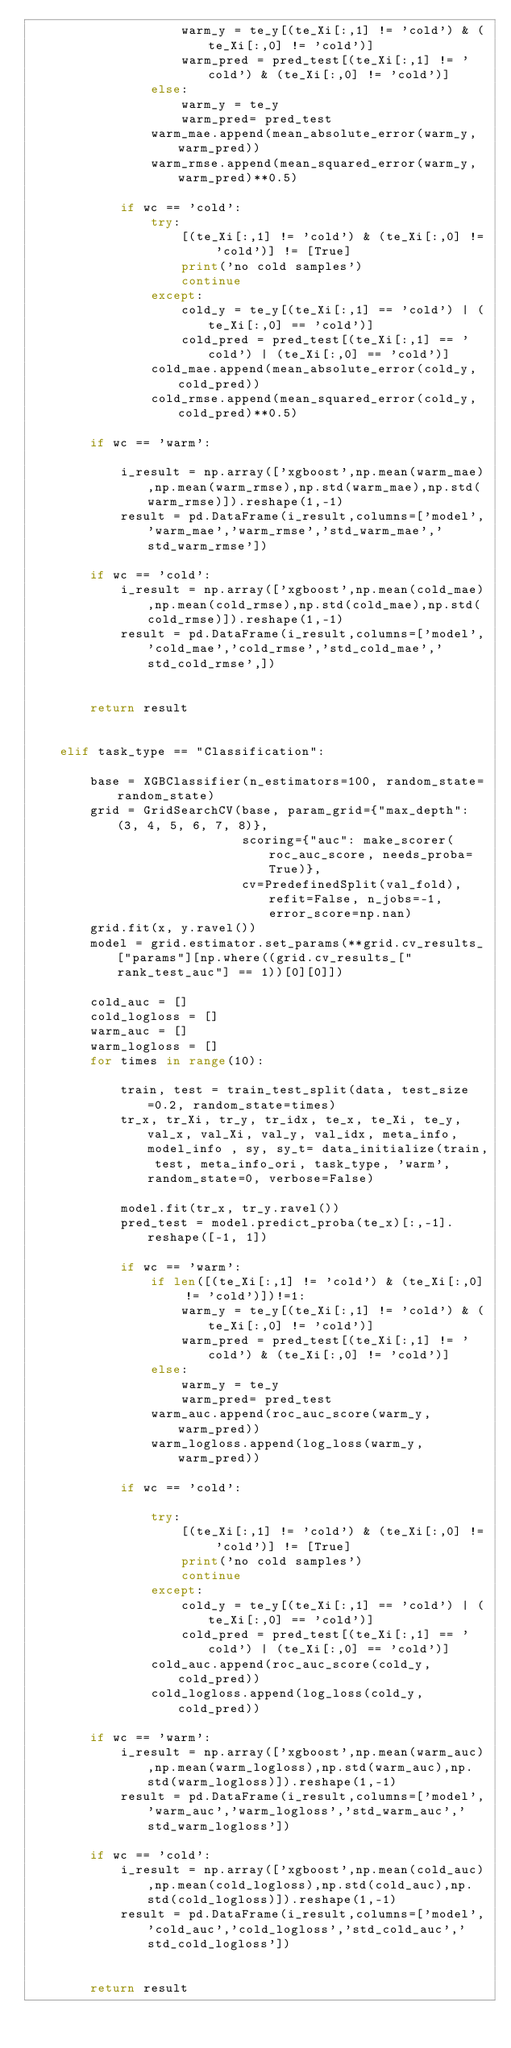Convert code to text. <code><loc_0><loc_0><loc_500><loc_500><_Python_>                    warm_y = te_y[(te_Xi[:,1] != 'cold') & (te_Xi[:,0] != 'cold')]
                    warm_pred = pred_test[(te_Xi[:,1] != 'cold') & (te_Xi[:,0] != 'cold')]
                else:
                    warm_y = te_y
                    warm_pred= pred_test
                warm_mae.append(mean_absolute_error(warm_y,warm_pred))
                warm_rmse.append(mean_squared_error(warm_y,warm_pred)**0.5)
                
            if wc == 'cold':
                try:
                    [(te_Xi[:,1] != 'cold') & (te_Xi[:,0] != 'cold')] != [True]
                    print('no cold samples')
                    continue
                except:
                    cold_y = te_y[(te_Xi[:,1] == 'cold') | (te_Xi[:,0] == 'cold')]
                    cold_pred = pred_test[(te_Xi[:,1] == 'cold') | (te_Xi[:,0] == 'cold')]
                cold_mae.append(mean_absolute_error(cold_y,cold_pred))
                cold_rmse.append(mean_squared_error(cold_y,cold_pred)**0.5)

        if wc == 'warm':
            
            i_result = np.array(['xgboost',np.mean(warm_mae),np.mean(warm_rmse),np.std(warm_mae),np.std(warm_rmse)]).reshape(1,-1)
            result = pd.DataFrame(i_result,columns=['model','warm_mae','warm_rmse','std_warm_mae','std_warm_rmse'])

        if wc == 'cold':  
            i_result = np.array(['xgboost',np.mean(cold_mae),np.mean(cold_rmse),np.std(cold_mae),np.std(cold_rmse)]).reshape(1,-1)
            result = pd.DataFrame(i_result,columns=['model','cold_mae','cold_rmse','std_cold_mae','std_cold_rmse',])
        

        return result


    elif task_type == "Classification":

        base = XGBClassifier(n_estimators=100, random_state=random_state)
        grid = GridSearchCV(base, param_grid={"max_depth": (3, 4, 5, 6, 7, 8)},
                            scoring={"auc": make_scorer(roc_auc_score, needs_proba=True)},
                            cv=PredefinedSplit(val_fold), refit=False, n_jobs=-1, error_score=np.nan)
        grid.fit(x, y.ravel())
        model = grid.estimator.set_params(**grid.cv_results_["params"][np.where((grid.cv_results_["rank_test_auc"] == 1))[0][0]])
        
        cold_auc = []
        cold_logloss = []
        warm_auc = []
        warm_logloss = []
        for times in range(10):
            
            train, test = train_test_split(data, test_size=0.2, random_state=times)
            tr_x, tr_Xi, tr_y, tr_idx, te_x, te_Xi, te_y, val_x, val_Xi, val_y, val_idx, meta_info, model_info , sy, sy_t= data_initialize(train, test, meta_info_ori, task_type, 'warm', random_state=0, verbose=False)

            model.fit(tr_x, tr_y.ravel())
            pred_test = model.predict_proba(te_x)[:,-1].reshape([-1, 1])
            
            if wc == 'warm':
                if len([(te_Xi[:,1] != 'cold') & (te_Xi[:,0] != 'cold')])!=1:
                    warm_y = te_y[(te_Xi[:,1] != 'cold') & (te_Xi[:,0] != 'cold')]
                    warm_pred = pred_test[(te_Xi[:,1] != 'cold') & (te_Xi[:,0] != 'cold')]
                else:
                    warm_y = te_y
                    warm_pred= pred_test
                warm_auc.append(roc_auc_score(warm_y,warm_pred))
                warm_logloss.append(log_loss(warm_y,warm_pred))   
                
            if wc == 'cold':
                
                try:
                    [(te_Xi[:,1] != 'cold') & (te_Xi[:,0] != 'cold')] != [True]
                    print('no cold samples')
                    continue
                except:
                    cold_y = te_y[(te_Xi[:,1] == 'cold') | (te_Xi[:,0] == 'cold')]
                    cold_pred = pred_test[(te_Xi[:,1] == 'cold') | (te_Xi[:,0] == 'cold')]
                cold_auc.append(roc_auc_score(cold_y,cold_pred))
                cold_logloss.append(log_loss(cold_y,cold_pred))

        if wc == 'warm':
            i_result = np.array(['xgboost',np.mean(warm_auc),np.mean(warm_logloss),np.std(warm_auc),np.std(warm_logloss)]).reshape(1,-1)
            result = pd.DataFrame(i_result,columns=['model','warm_auc','warm_logloss','std_warm_auc','std_warm_logloss'])

        if wc == 'cold':
            i_result = np.array(['xgboost',np.mean(cold_auc),np.mean(cold_logloss),np.std(cold_auc),np.std(cold_logloss)]).reshape(1,-1)
            result = pd.DataFrame(i_result,columns=['model','cold_auc','cold_logloss','std_cold_auc','std_cold_logloss'])
            

        return result</code> 